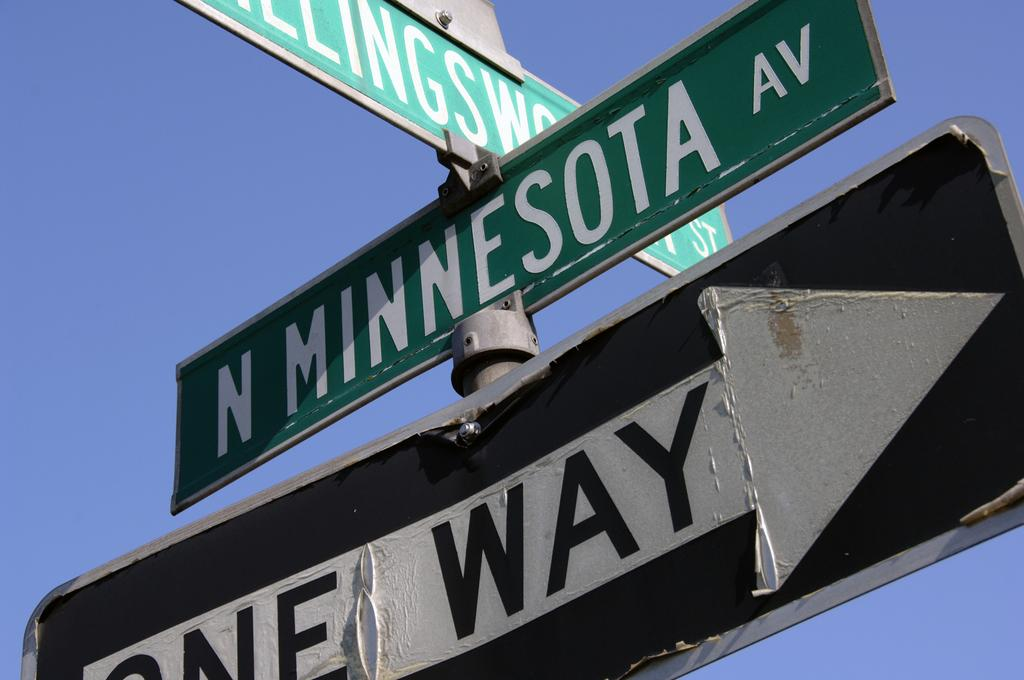<image>
Render a clear and concise summary of the photo. A street sign for north Minnesota Ave has a one way sign right underneath it. 